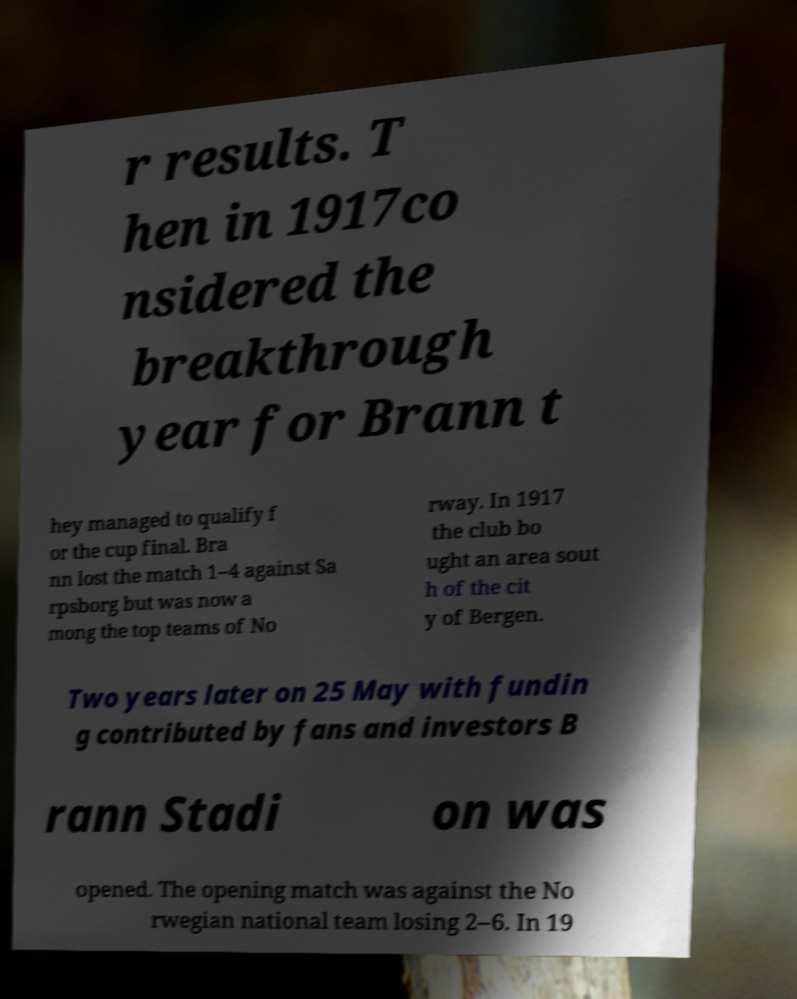Please identify and transcribe the text found in this image. r results. T hen in 1917co nsidered the breakthrough year for Brann t hey managed to qualify f or the cup final. Bra nn lost the match 1–4 against Sa rpsborg but was now a mong the top teams of No rway. In 1917 the club bo ught an area sout h of the cit y of Bergen. Two years later on 25 May with fundin g contributed by fans and investors B rann Stadi on was opened. The opening match was against the No rwegian national team losing 2–6. In 19 